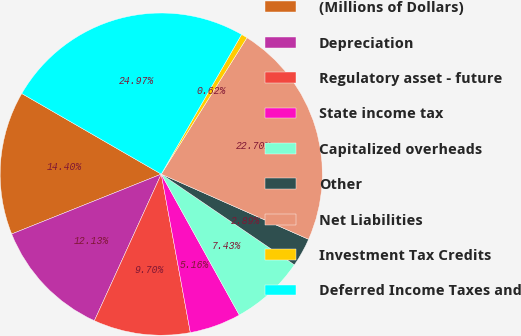<chart> <loc_0><loc_0><loc_500><loc_500><pie_chart><fcel>(Millions of Dollars)<fcel>Depreciation<fcel>Regulatory asset - future<fcel>State income tax<fcel>Capitalized overheads<fcel>Other<fcel>Net Liabilities<fcel>Investment Tax Credits<fcel>Deferred Income Taxes and<nl><fcel>14.4%<fcel>12.13%<fcel>9.7%<fcel>5.16%<fcel>7.43%<fcel>2.89%<fcel>22.7%<fcel>0.62%<fcel>24.97%<nl></chart> 